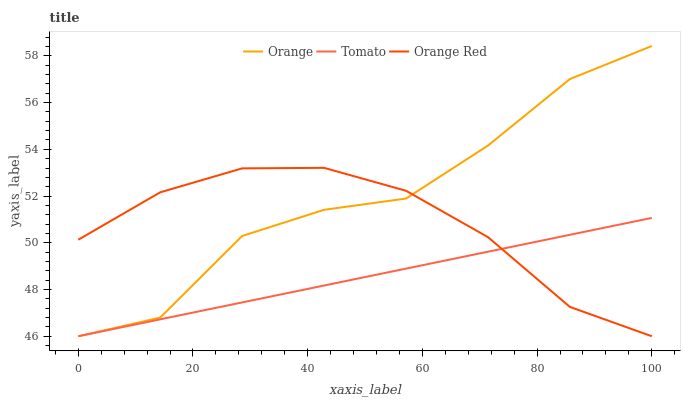Does Tomato have the minimum area under the curve?
Answer yes or no. Yes. Does Orange have the maximum area under the curve?
Answer yes or no. Yes. Does Orange Red have the minimum area under the curve?
Answer yes or no. No. Does Orange Red have the maximum area under the curve?
Answer yes or no. No. Is Tomato the smoothest?
Answer yes or no. Yes. Is Orange the roughest?
Answer yes or no. Yes. Is Orange Red the smoothest?
Answer yes or no. No. Is Orange Red the roughest?
Answer yes or no. No. Does Orange have the lowest value?
Answer yes or no. Yes. Does Orange have the highest value?
Answer yes or no. Yes. Does Orange Red have the highest value?
Answer yes or no. No. Does Tomato intersect Orange Red?
Answer yes or no. Yes. Is Tomato less than Orange Red?
Answer yes or no. No. Is Tomato greater than Orange Red?
Answer yes or no. No. 